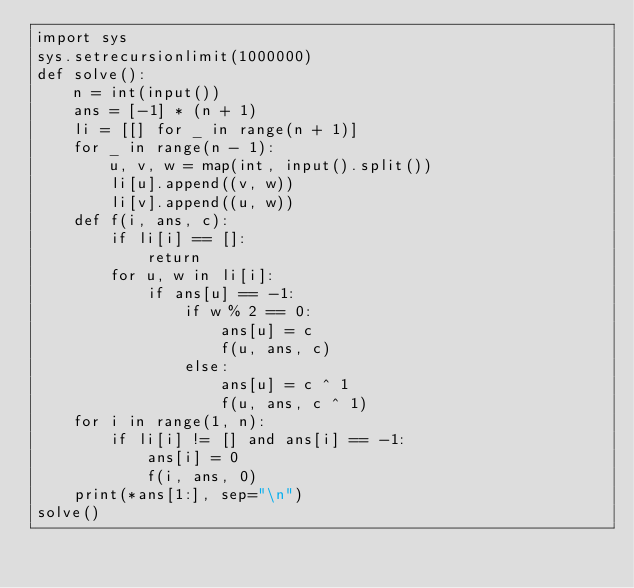<code> <loc_0><loc_0><loc_500><loc_500><_Python_>import sys
sys.setrecursionlimit(1000000)
def solve():
    n = int(input())
    ans = [-1] * (n + 1)
    li = [[] for _ in range(n + 1)]
    for _ in range(n - 1):
        u, v, w = map(int, input().split())
        li[u].append((v, w))
        li[v].append((u, w))
    def f(i, ans, c):
        if li[i] == []:
            return
        for u, w in li[i]:
            if ans[u] == -1:
                if w % 2 == 0:
                    ans[u] = c
                    f(u, ans, c)
                else:
                    ans[u] = c ^ 1
                    f(u, ans, c ^ 1)
    for i in range(1, n):
        if li[i] != [] and ans[i] == -1:
            ans[i] = 0
            f(i, ans, 0)
    print(*ans[1:], sep="\n")
solve()
</code> 